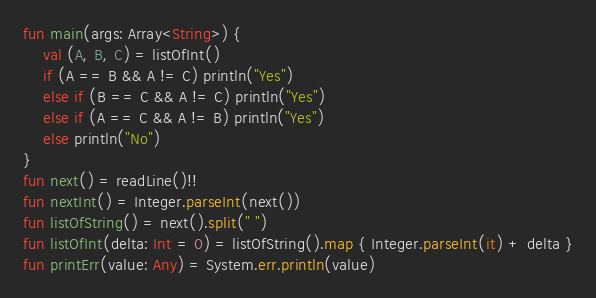<code> <loc_0><loc_0><loc_500><loc_500><_Kotlin_>fun main(args: Array<String>) {
    val (A, B, C) = listOfInt()
    if (A == B && A != C) println("Yes")
    else if (B == C && A != C) println("Yes")
    else if (A == C && A != B) println("Yes")
    else println("No")
}
fun next() = readLine()!!
fun nextInt() = Integer.parseInt(next())
fun listOfString() = next().split(" ")
fun listOfInt(delta: Int = 0) = listOfString().map { Integer.parseInt(it) + delta }
fun printErr(value: Any) = System.err.println(value)
</code> 